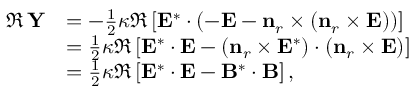Convert formula to latex. <formula><loc_0><loc_0><loc_500><loc_500>\begin{array} { r l } { \Re \, Y } & { = - \frac { 1 } { 2 } \kappa \Re \left [ E ^ { * } \cdot \left ( - E - n _ { r } \times \left ( n _ { r } \times E \right ) \right ) \right ] } \\ & { = \frac { 1 } { 2 } \kappa \Re \left [ E ^ { * } \cdot E - \left ( n _ { r } \times E ^ { * } \right ) \cdot \left ( n _ { r } \times E \right ) \right ] } \\ & { = \frac { 1 } { 2 } \kappa \Re \left [ E ^ { * } \cdot E - B ^ { * } \cdot B \right ] , } \end{array}</formula> 